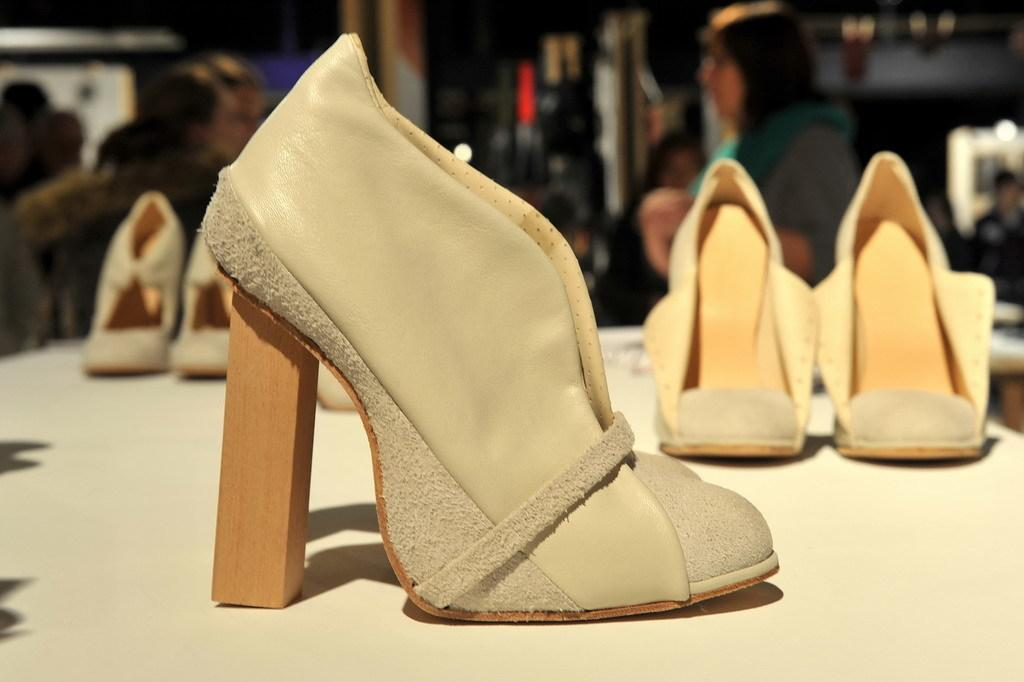What type of objects can be seen in the image? There are pairs of footwear in the image. What colors are the footwear? The footwear colors include brown and gray. Can you describe the background of the image? The background of the image is blurred. What type of soup is being served in the glass in the image? There is no glass or soup present in the image; it only features pairs of footwear. 